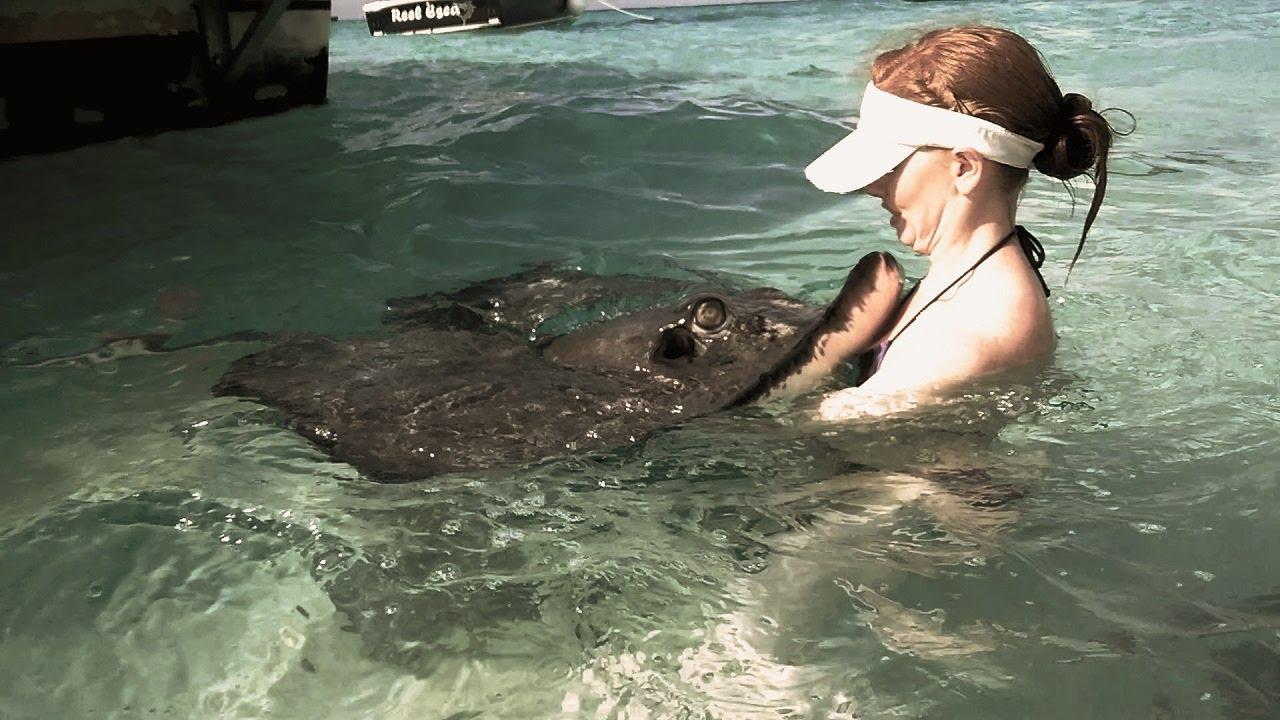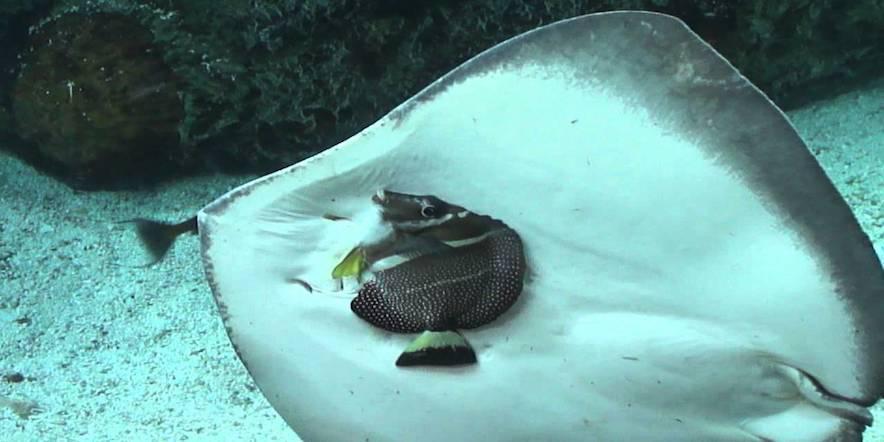The first image is the image on the left, the second image is the image on the right. Analyze the images presented: Is the assertion "In one image there is a ray that is swimming very close to the ocean floor." valid? Answer yes or no. No. The first image is the image on the left, the second image is the image on the right. Analyze the images presented: Is the assertion "the left images shows a stingray swimming with the full under belly showing" valid? Answer yes or no. No. 